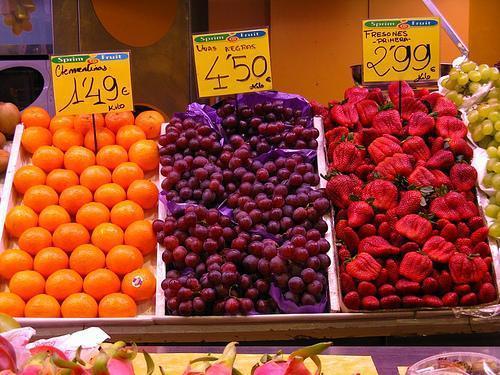How many different fruit are there?
Give a very brief answer. 4. 